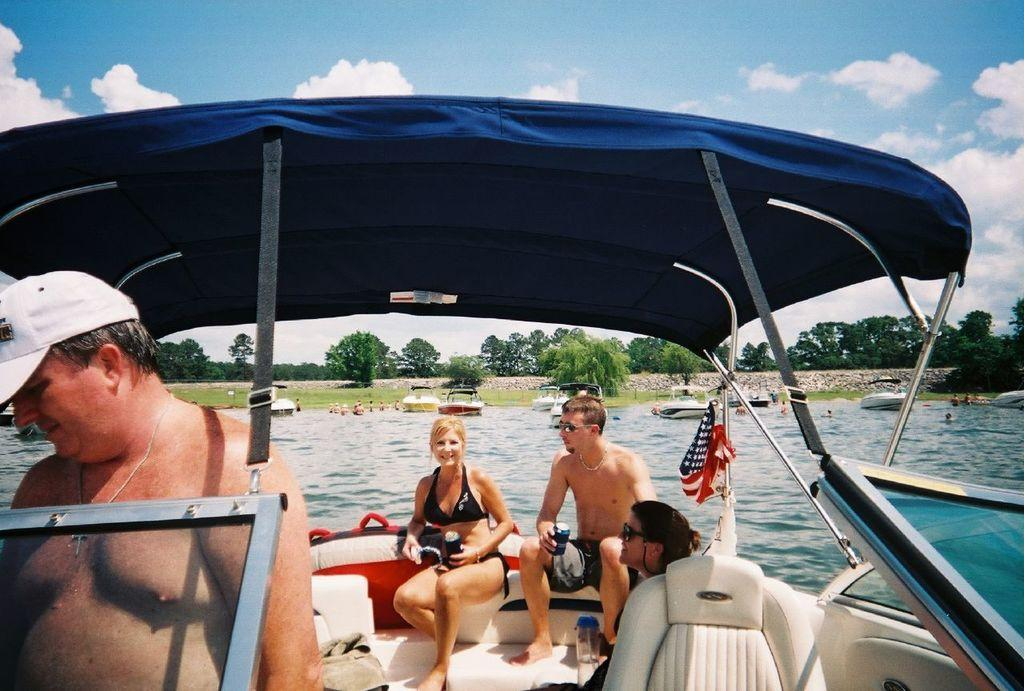What are the people in the image doing? The people are in a boat. What can be seen flying above the water and people? There are boats visible above the water and people. What is the background of the image? The background of the image includes trees and the sky. What is the condition of the sky in the image? The sky is visible in the background of the image, and clouds are present. What type of eggnog is being served on the railway in the image? There is no railway or eggnog present in the image; it features people in a boat with a flag and trees in the background. 